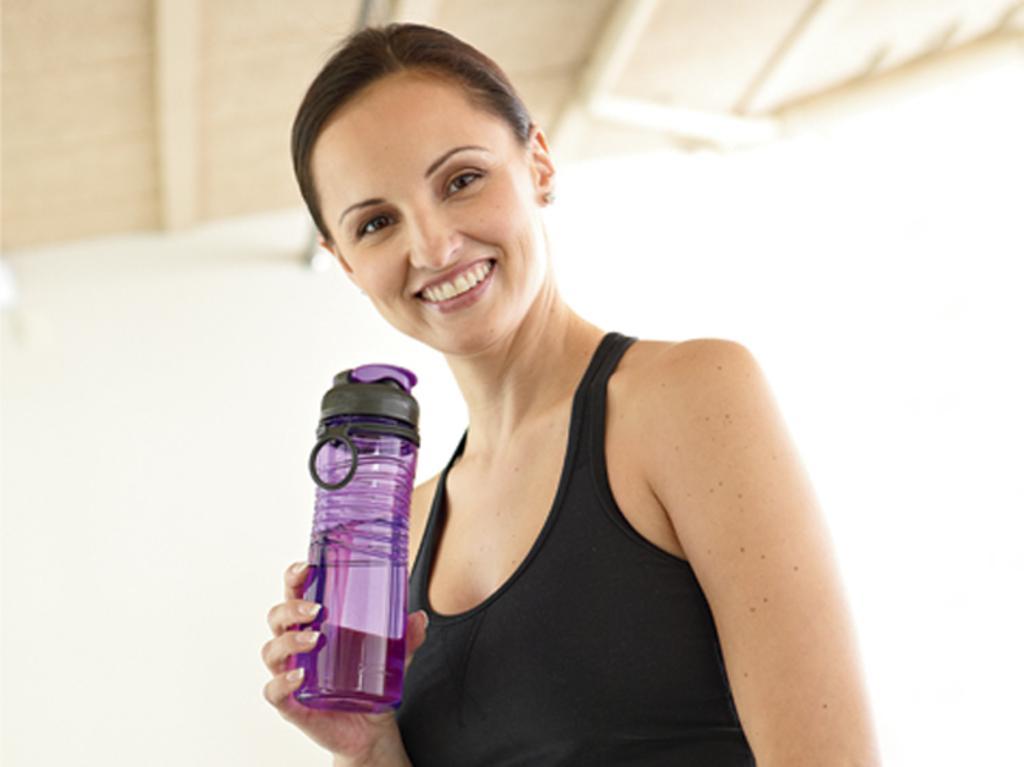In one or two sentences, can you explain what this image depicts? In this image, woman in black color. She hold a water bottle in his hand. And back side, we can see a roof cream color one. 